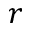<formula> <loc_0><loc_0><loc_500><loc_500>r</formula> 